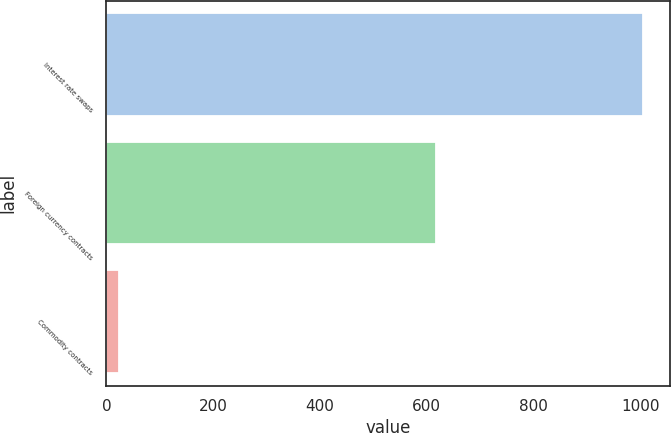Convert chart to OTSL. <chart><loc_0><loc_0><loc_500><loc_500><bar_chart><fcel>Interest rate swaps<fcel>Foreign currency contracts<fcel>Commodity contracts<nl><fcel>1006<fcel>618.3<fcel>24.2<nl></chart> 